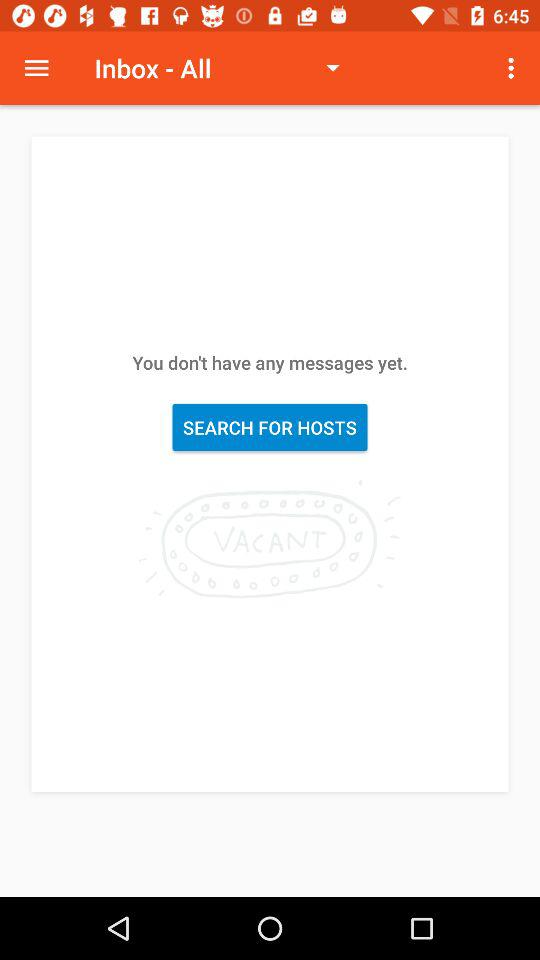How many messages are received? You don't have any messages. 